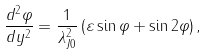<formula> <loc_0><loc_0><loc_500><loc_500>\frac { d ^ { 2 } \varphi } { d y ^ { 2 } } = \frac { 1 } { \lambda _ { J 0 } ^ { 2 } } \left ( \varepsilon \sin \varphi + \sin 2 \varphi \right ) ,</formula> 